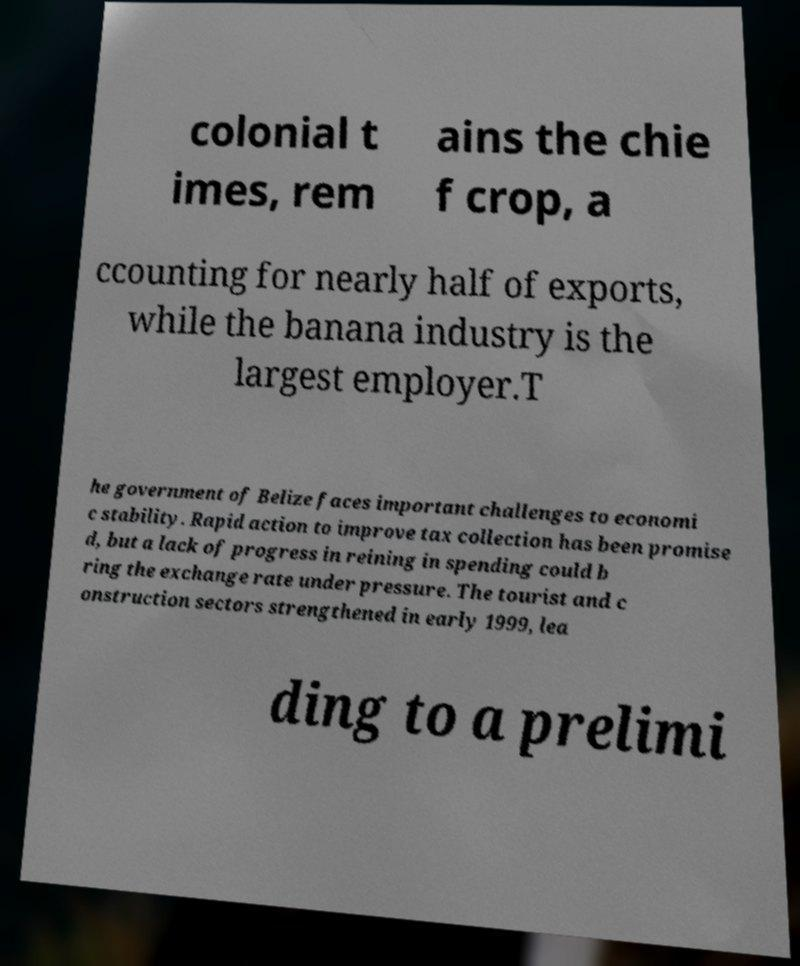Please read and relay the text visible in this image. What does it say? colonial t imes, rem ains the chie f crop, a ccounting for nearly half of exports, while the banana industry is the largest employer.T he government of Belize faces important challenges to economi c stability. Rapid action to improve tax collection has been promise d, but a lack of progress in reining in spending could b ring the exchange rate under pressure. The tourist and c onstruction sectors strengthened in early 1999, lea ding to a prelimi 